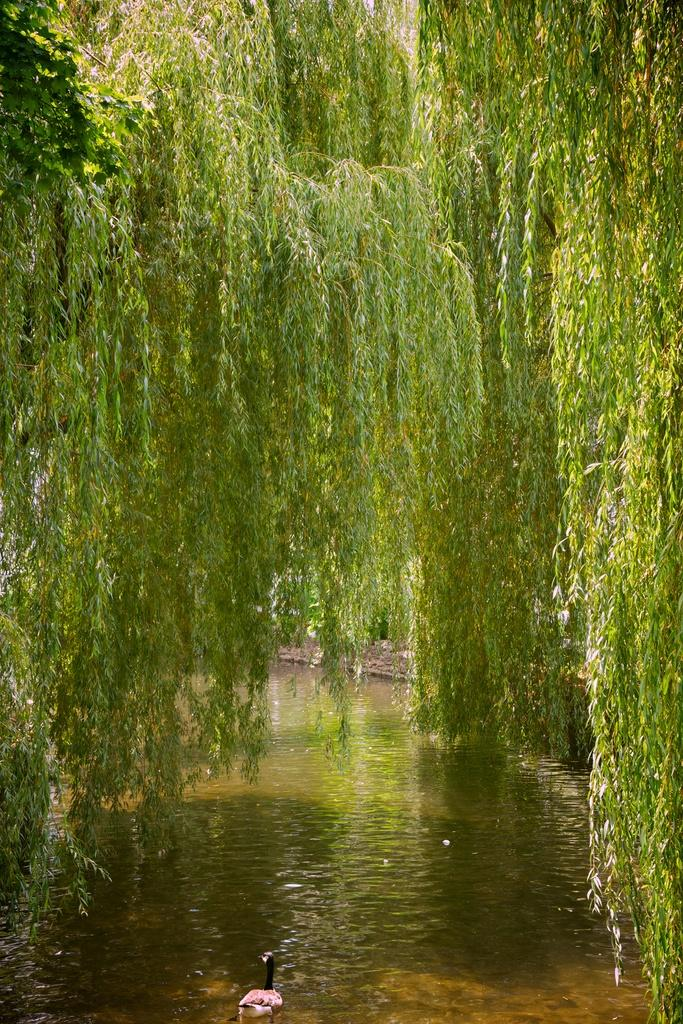What is located in the center of the image? There are trees and water in the center of the image. Can you describe the bird in the image? There is a bird in the water in the image. What type of environment is depicted in the image? The image features a natural environment with trees and water. How many clams can be seen on the trees in the image? There are no clams present in the image; it features trees and water with a bird in the water. What type of apples are hanging from the branches of the trees in the image? There are no apples present in the image; it features trees and water with a bird in the water. 